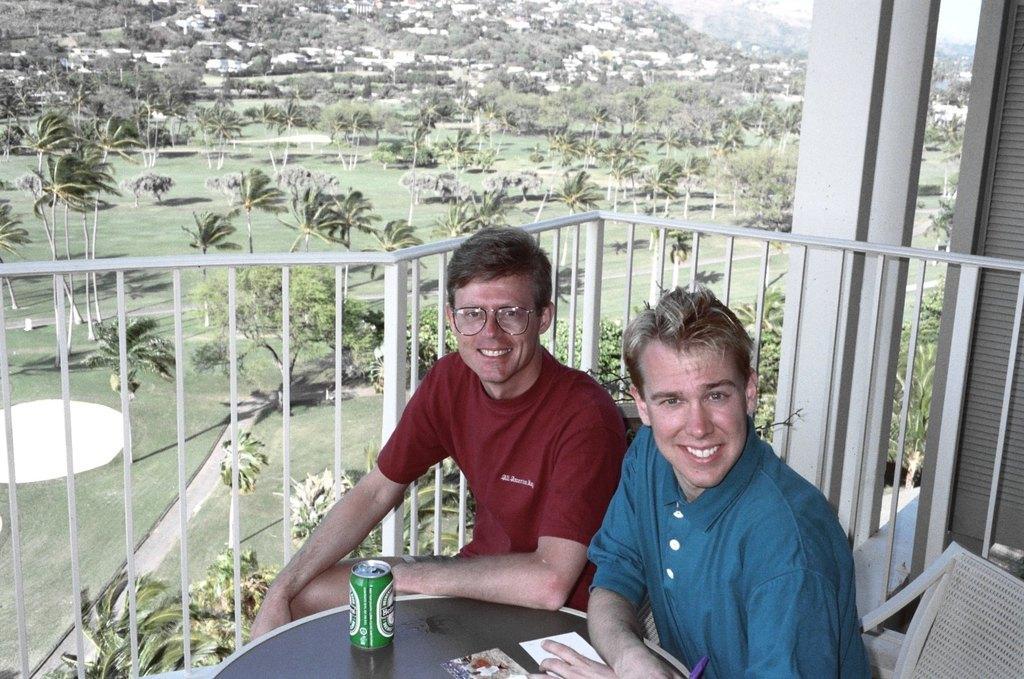How would you summarize this image in a sentence or two? In this picture there are two boys those who are sitting on the chair by resting their hands on the table, there is a cool drink on the table, there are trees and full of greenery around the area behind the boys in the image. 